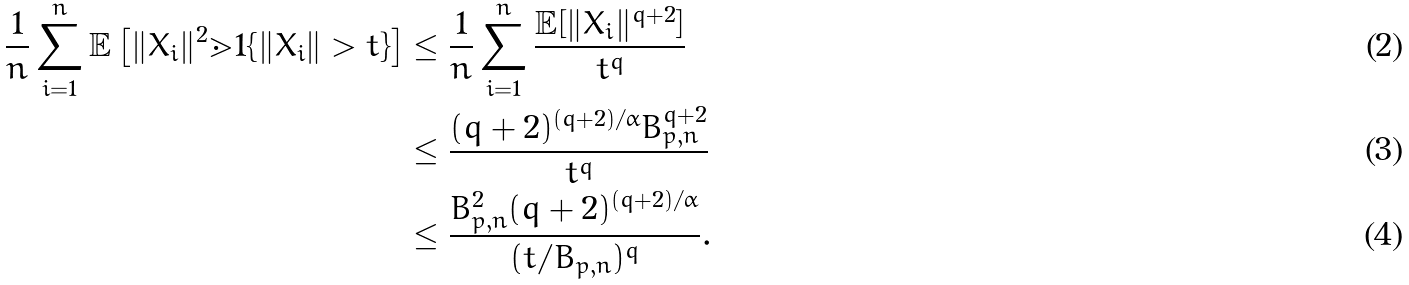<formula> <loc_0><loc_0><loc_500><loc_500>\frac { 1 } { n } \sum _ { i = 1 } ^ { n } \mathbb { E } \left [ \| X _ { i } \| ^ { 2 } \mathbb { m } { 1 } \{ \| X _ { i } \| > t \} \right ] & \leq \frac { 1 } { n } \sum _ { i = 1 } ^ { n } \frac { \mathbb { E } [ \| X _ { i } \| ^ { q + 2 } ] } { t ^ { q } } \\ & \leq \frac { ( q + 2 ) ^ { ( q + 2 ) / \alpha } B _ { p , n } ^ { q + 2 } } { t ^ { q } } \\ & \leq \frac { B _ { p , n } ^ { 2 } ( q + 2 ) ^ { ( q + 2 ) / \alpha } } { ( t / B _ { p , n } ) ^ { q } } .</formula> 